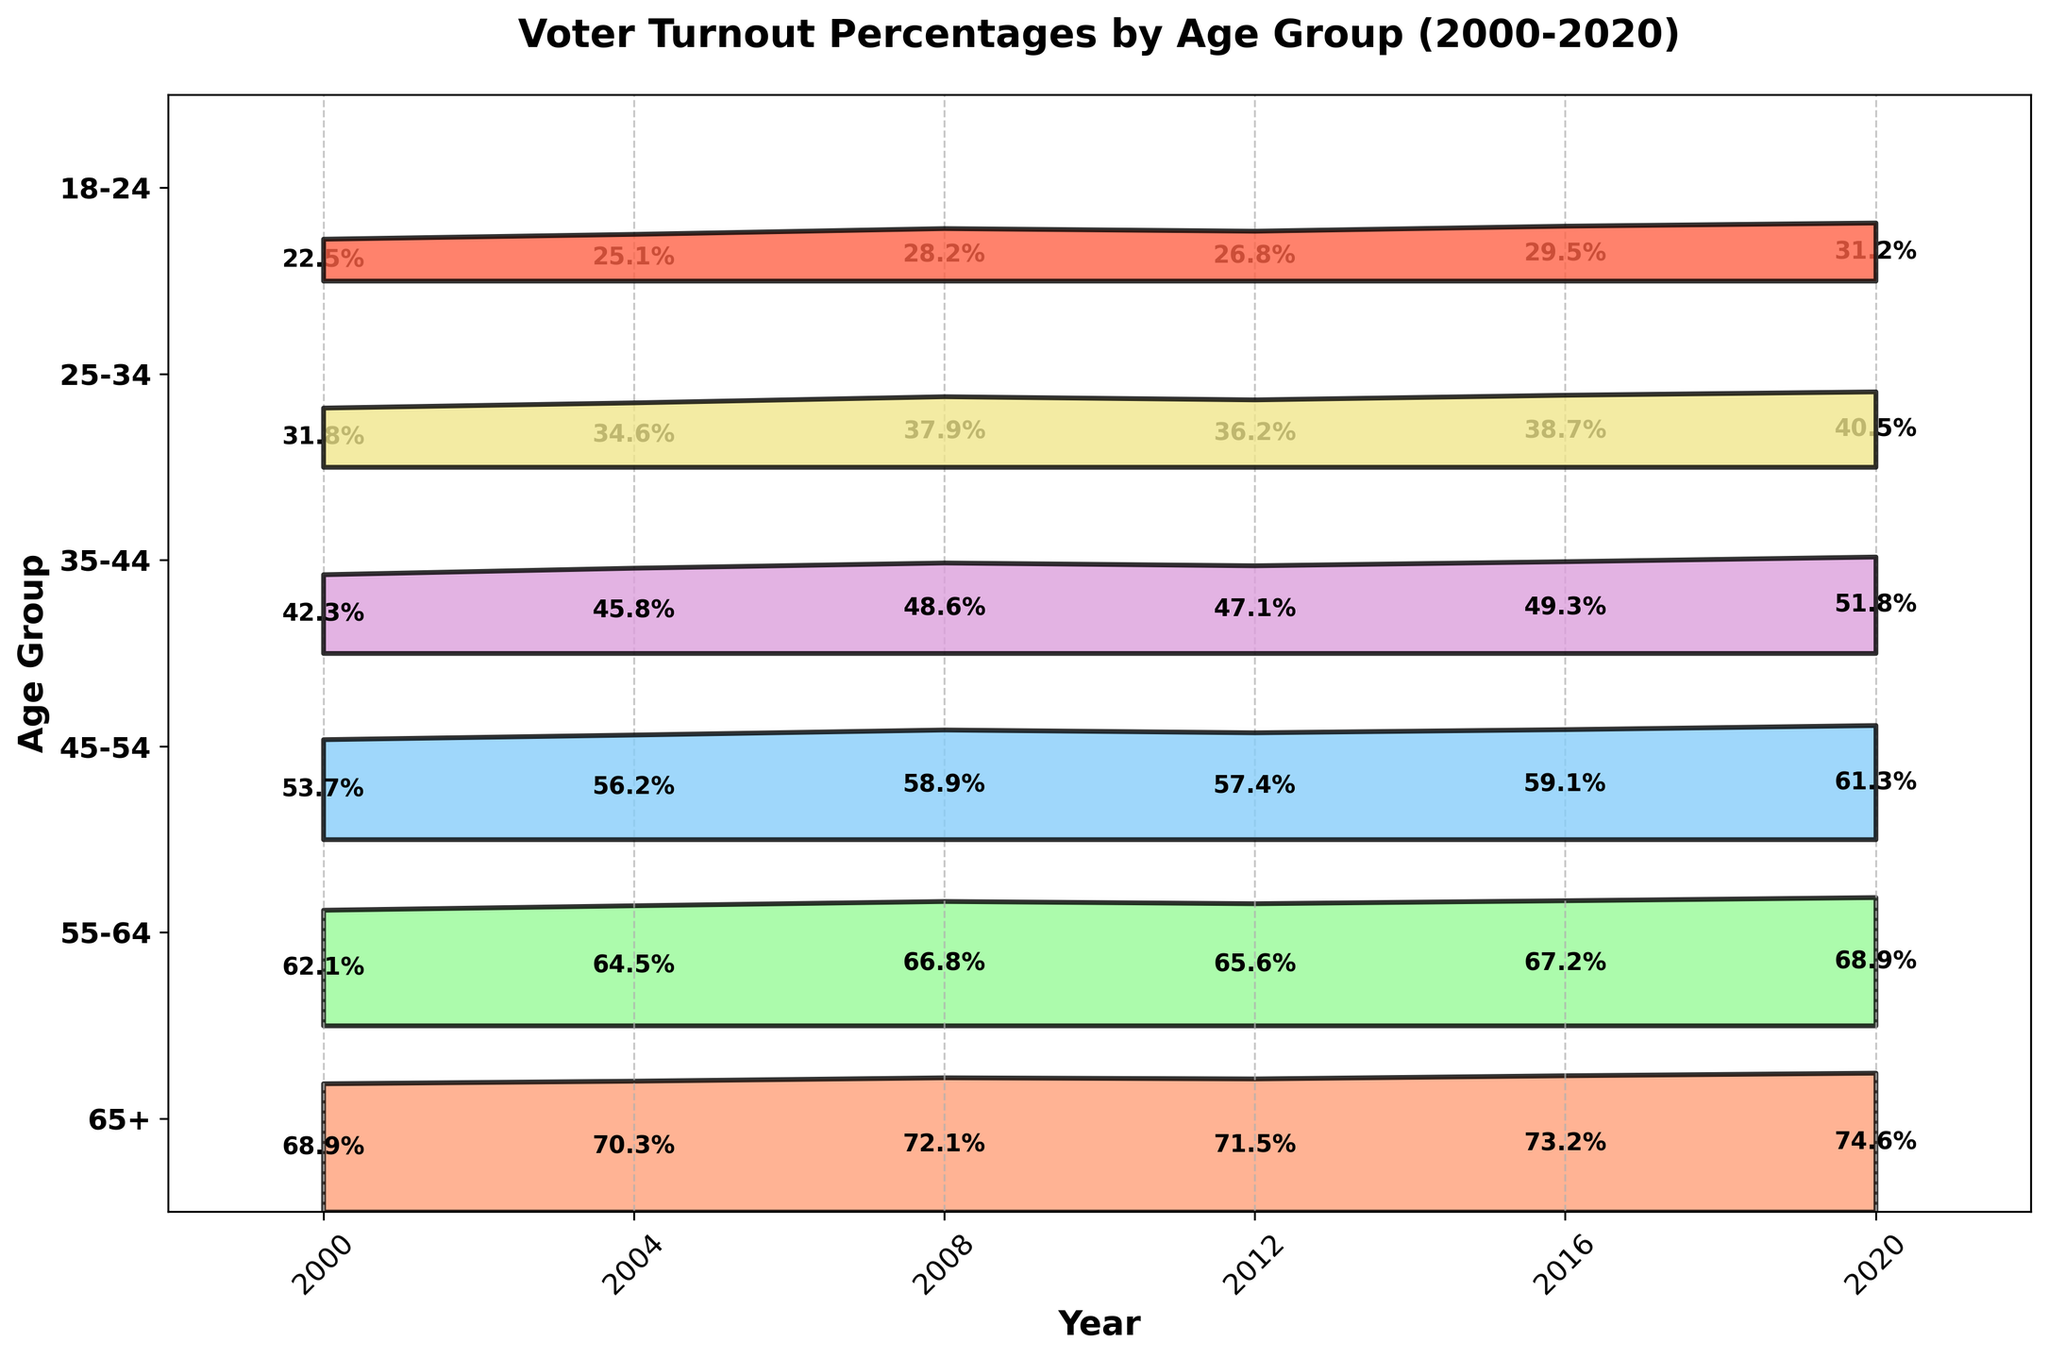What is the title of the figure? The title is usually located at the top of the figure. In this case, it reads "Voter Turnout Percentages by Age Group (2000-2020)."
Answer: Voter Turnout Percentages by Age Group (2000-2020) How many age groups are presented in the figure? Each age group corresponds to a distinct color-coded band in the figure. There are six different age groups shown.
Answer: 6 What was the voter turnout percentage for the age group 18-24 in 2000? Look at the band labeled "18-24" and find the point corresponding to the year 2000. The number written inside the band at this point is the voter turnout percentage.
Answer: 22.5% Which age group had the highest voter turnout in 2020? Find the year 2020 on the x-axis, then look for the highest point among the different age groups. The group with the highest percentage will be at the topmost position.
Answer: 65+ Compare the voter turnout percentage of the 25-34 age group in 2000 and 2020. Which year had higher turnout and by how much? Locate the label for "25-34" and check the turnout percentages for the years 2000 and 2020. Calculate the difference by subtracting the turnout in 2000 from the turnout in 2020.
Answer: 2020 by 8.7% What trends can you observe in voter turnout for the 65+ age group from 2000 to 2020? Follow the band corresponding to the "65+" age group from the start (2000) to the end (2020). Note if the turnout percentage is increasing, decreasing, or fluctuating over time.
Answer: Increasing What is the overall range of voter turnout percentages for the 45-54 age group in all presented years? Identify the highest and lowest voter turnout percentages within the "45-54" band across all years. Subtract the lowest value from the highest to determine the range.
Answer: 61.3% - 53.7% = 7.6% How did the voter turnout percentage for the 35-44 age group change between 2004 and 2008? Check the "35-44" band and compare the voter turnout percentages for the years 2004 and 2008. Determine if it increased or decreased, and by how much.
Answer: Increased by 2.8% What is the average voter turnout percentage for the 55-64 age group across all presented years? Locate all the voter turnout percentages for the "55-64" age group across each year listed. Sum these values and divide by the number of years to find the average.
Answer: (62.1 + 64.5 + 66.8 + 65.6 + 67.2 + 68.9) / 6 = 65.85% Do older age groups generally have higher voter turnout percentages compared to younger age groups? Compare the bands of older age groups (e.g., 55-64, 65+) with those of younger age groups (e.g., 18-24, 25-34) across the years. Notice if the percentages are higher for older groups.
Answer: Yes 